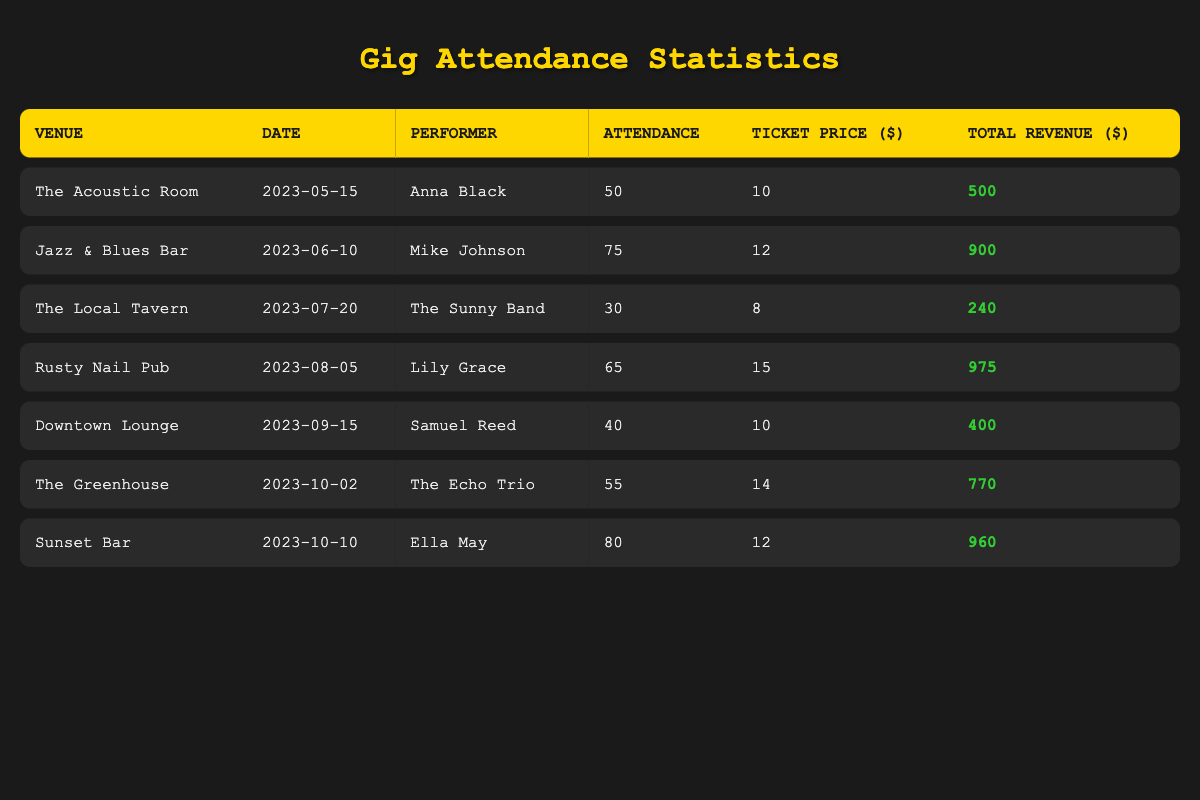What was the total attendance across all gigs? To find the total attendance, sum the attendance numbers from each venue: 50 + 75 + 30 + 65 + 40 + 55 + 80 = 395.
Answer: 395 Which performer had the highest attendance? The highest attendance was 80, which corresponds to Ella May at Sunset Bar on 2023-10-10.
Answer: Ella May Was the ticket price at The Local Tavern higher than at Downtown Lounge? The ticket price at The Local Tavern was 8, and at Downtown Lounge it was 10. Since 8 is less than 10, the answer is no.
Answer: No What is the average ticket price across all venues? To calculate the average ticket price, sum the ticket prices (10 + 12 + 8 + 15 + 10 + 14 + 12 = 91) and divide by the number of venues (7). So, 91 / 7 = 13.
Answer: 13 How much total revenue did Lily Grace generate at Rusty Nail Pub? The total revenue generated by Lily Grace at Rusty Nail Pub is listed as 975.
Answer: 975 Did any venue have an attendance of over 70? Looking at the attendance numbers, Jazz & Blues Bar had 75, Rusty Nail Pub had 65, and Sunset Bar had 80. Since 75 and 80 are both over 70, the answer is yes.
Answer: Yes What is the difference in total revenue between The Acoustic Room and Jazz & Blues Bar? The total revenue for The Acoustic Room is 500 and for Jazz & Blues Bar is 900. The difference is 900 - 500 = 400.
Answer: 400 How many performers had an attendance of less than 50? The only gig with an attendance under 50 is at The Local Tavern with 30 attendees. Therefore, only one performer had less than 50 attendees.
Answer: 1 Which venue had the lowest total revenue? The total revenues for each venue are: The Acoustic Room - 500, Jazz & Blues Bar - 900, The Local Tavern - 240, Rusty Nail Pub - 975, Downtown Lounge - 400, The Greenhouse - 770, Sunset Bar - 960. The lowest is The Local Tavern with 240.
Answer: The Local Tavern 